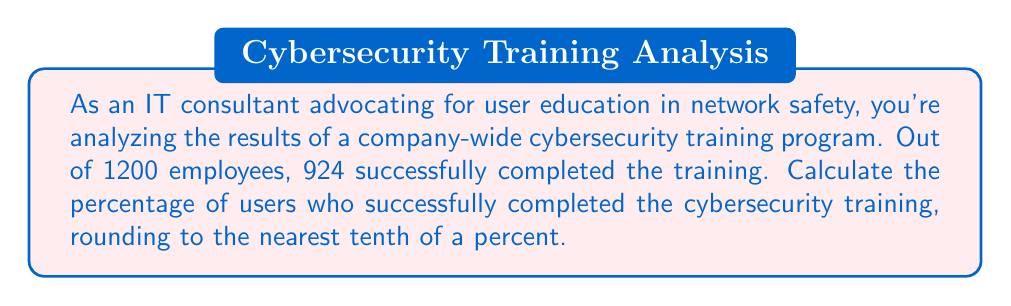What is the answer to this math problem? To calculate the percentage of users who successfully completed the cybersecurity training, we need to divide the number of employees who completed the training by the total number of employees, then multiply by 100.

Let's break it down step-by-step:

1. Number of employees who completed the training: 924
2. Total number of employees: 1200

The formula for calculating percentage is:

$$ \text{Percentage} = \frac{\text{Number of successful completions}}{\text{Total number of employees}} \times 100 $$

Plugging in our values:

$$ \text{Percentage} = \frac{924}{1200} \times 100 $$

Now, let's solve this:

$$ \begin{align*}
\text{Percentage} &= \frac{924}{1200} \times 100 \\[6pt]
&= 0.77 \times 100 \\[6pt]
&= 77\%
\end{align*} $$

Since we need to round to the nearest tenth of a percent, our final answer is 77.0%.

This result shows that more than three-quarters of the employees successfully completed the cybersecurity training, which is valuable information for an IT consultant advocating for user education in network safety.
Answer: 77.0% 